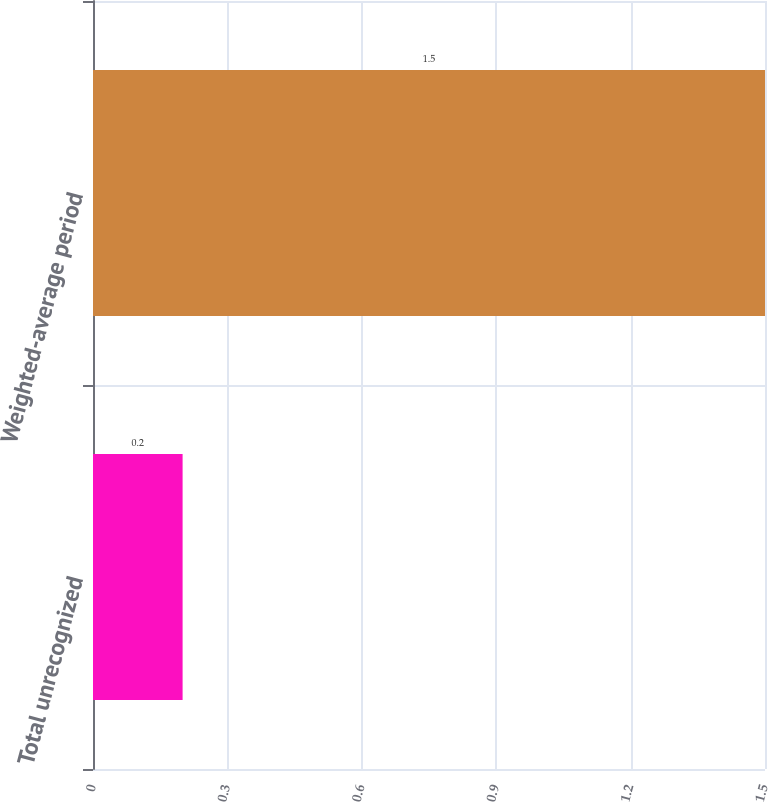Convert chart. <chart><loc_0><loc_0><loc_500><loc_500><bar_chart><fcel>Total unrecognized<fcel>Weighted-average period<nl><fcel>0.2<fcel>1.5<nl></chart> 